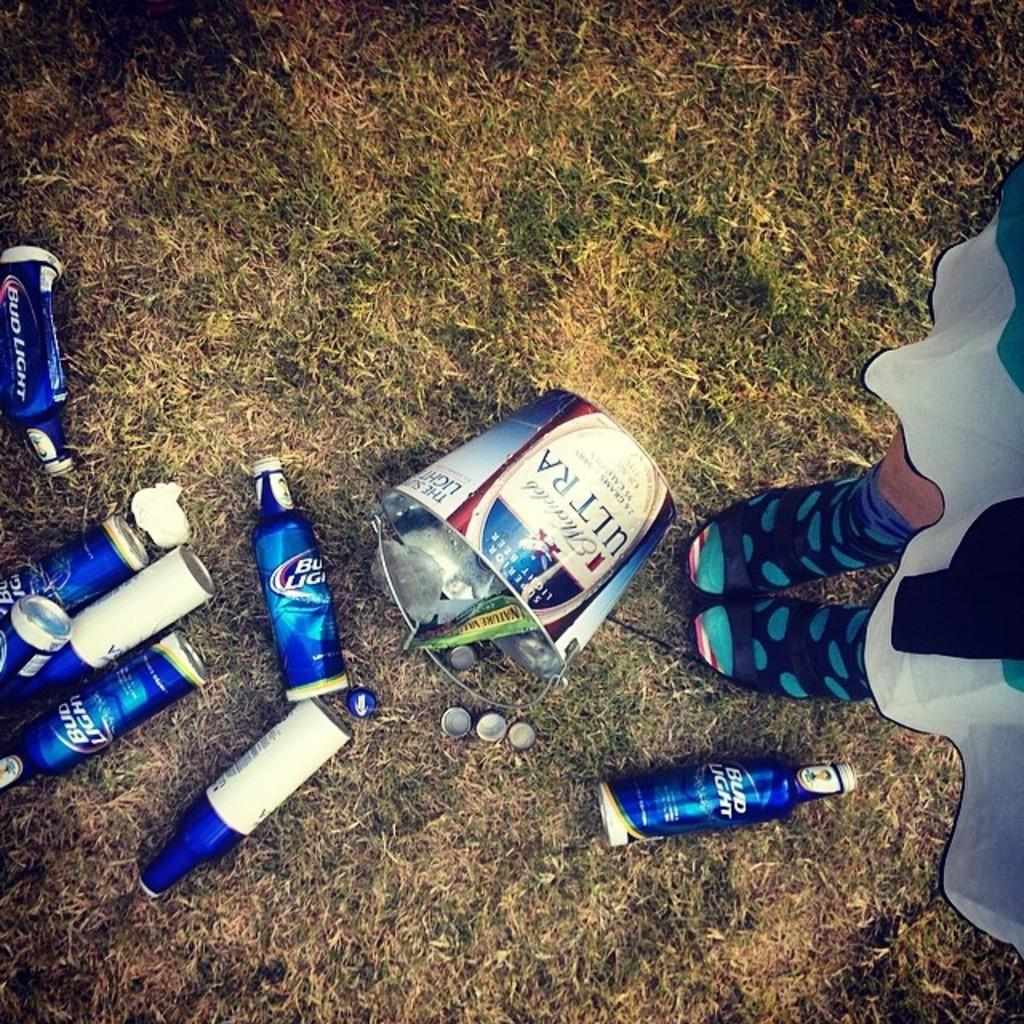Provide a one-sentence caption for the provided image. A spiled beer bucket with empty bud light bottles around it. 